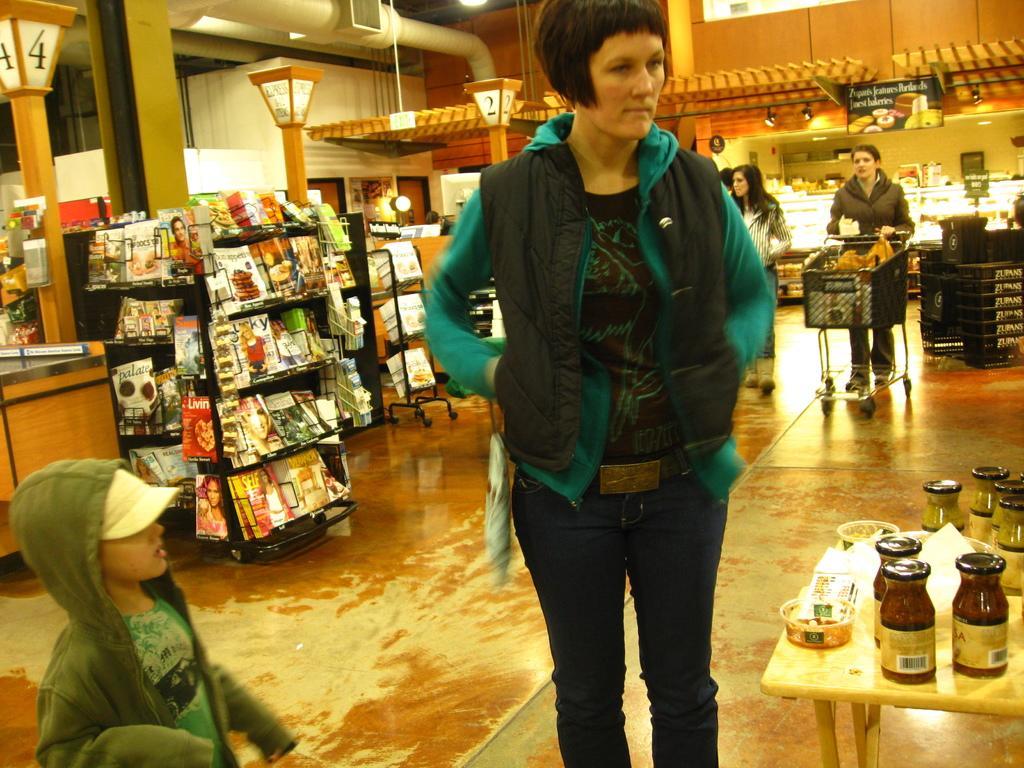How would you summarize this image in a sentence or two? In this image I can see a group of people on the floor, tables, bottles and so on. In the background I can see cupboards, magazines, wall, AC duct and so on. This image is taken in a shopping mall. 